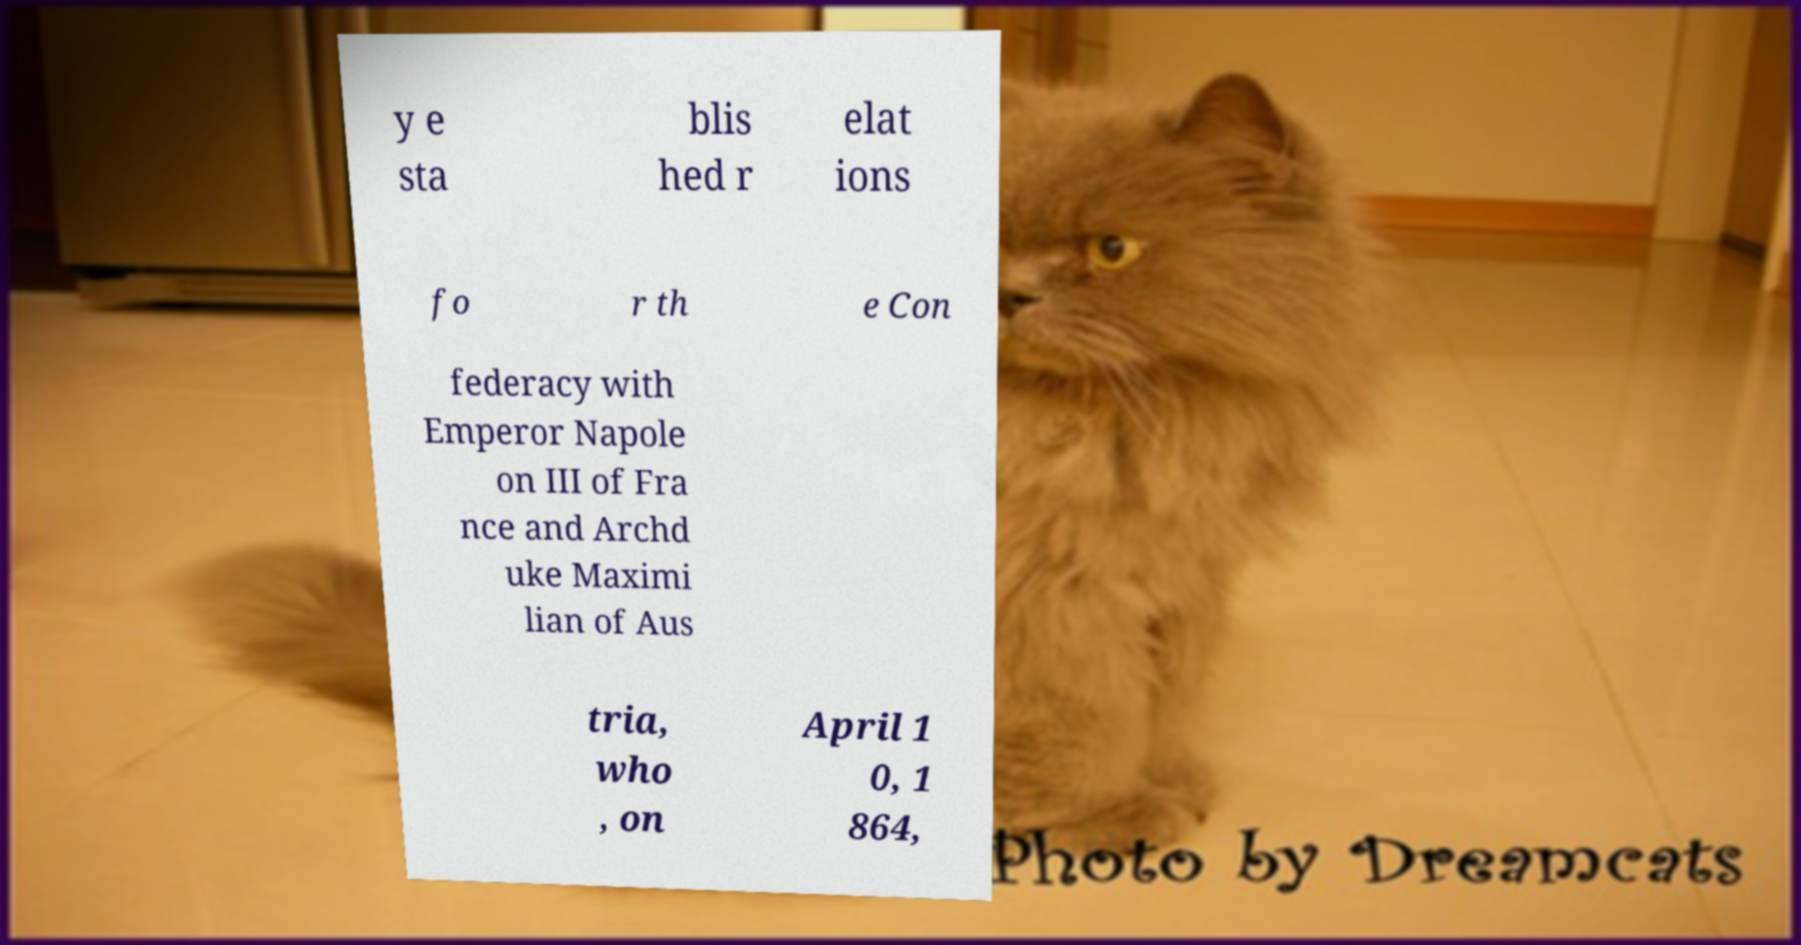Please identify and transcribe the text found in this image. y e sta blis hed r elat ions fo r th e Con federacy with Emperor Napole on III of Fra nce and Archd uke Maximi lian of Aus tria, who , on April 1 0, 1 864, 